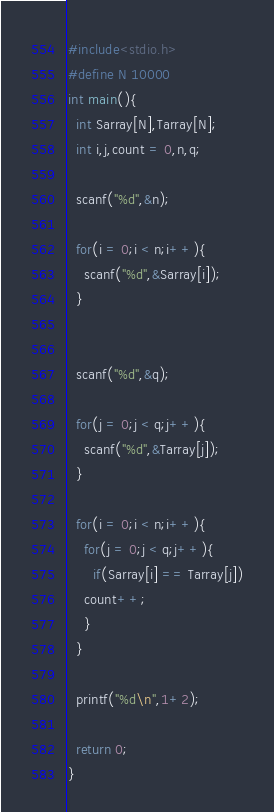<code> <loc_0><loc_0><loc_500><loc_500><_C_>#include<stdio.h>
#define N 10000
int main(){
  int Sarray[N],Tarray[N];
  int i,j,count = 0,n,q;
  
  scanf("%d",&n);

  for(i = 0;i < n;i++){
    scanf("%d",&Sarray[i]);
  }
  

  scanf("%d",&q);

  for(j = 0;j < q;j++){
    scanf("%d",&Tarray[j]);
  }

  for(i = 0;i < n;i++){
    for(j = 0;j < q;j++){
      if(Sarray[i] == Tarray[j])
	count++;
    }
  }

  printf("%d\n",1+2);

  return 0;
}</code> 